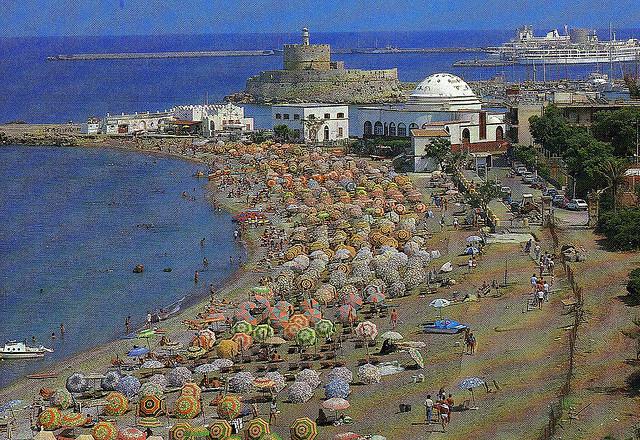What are all the round objects on the beach?
Keep it brief. Umbrellas. Is this a beach?
Concise answer only. Yes. What color is the water?
Give a very brief answer. Blue. 